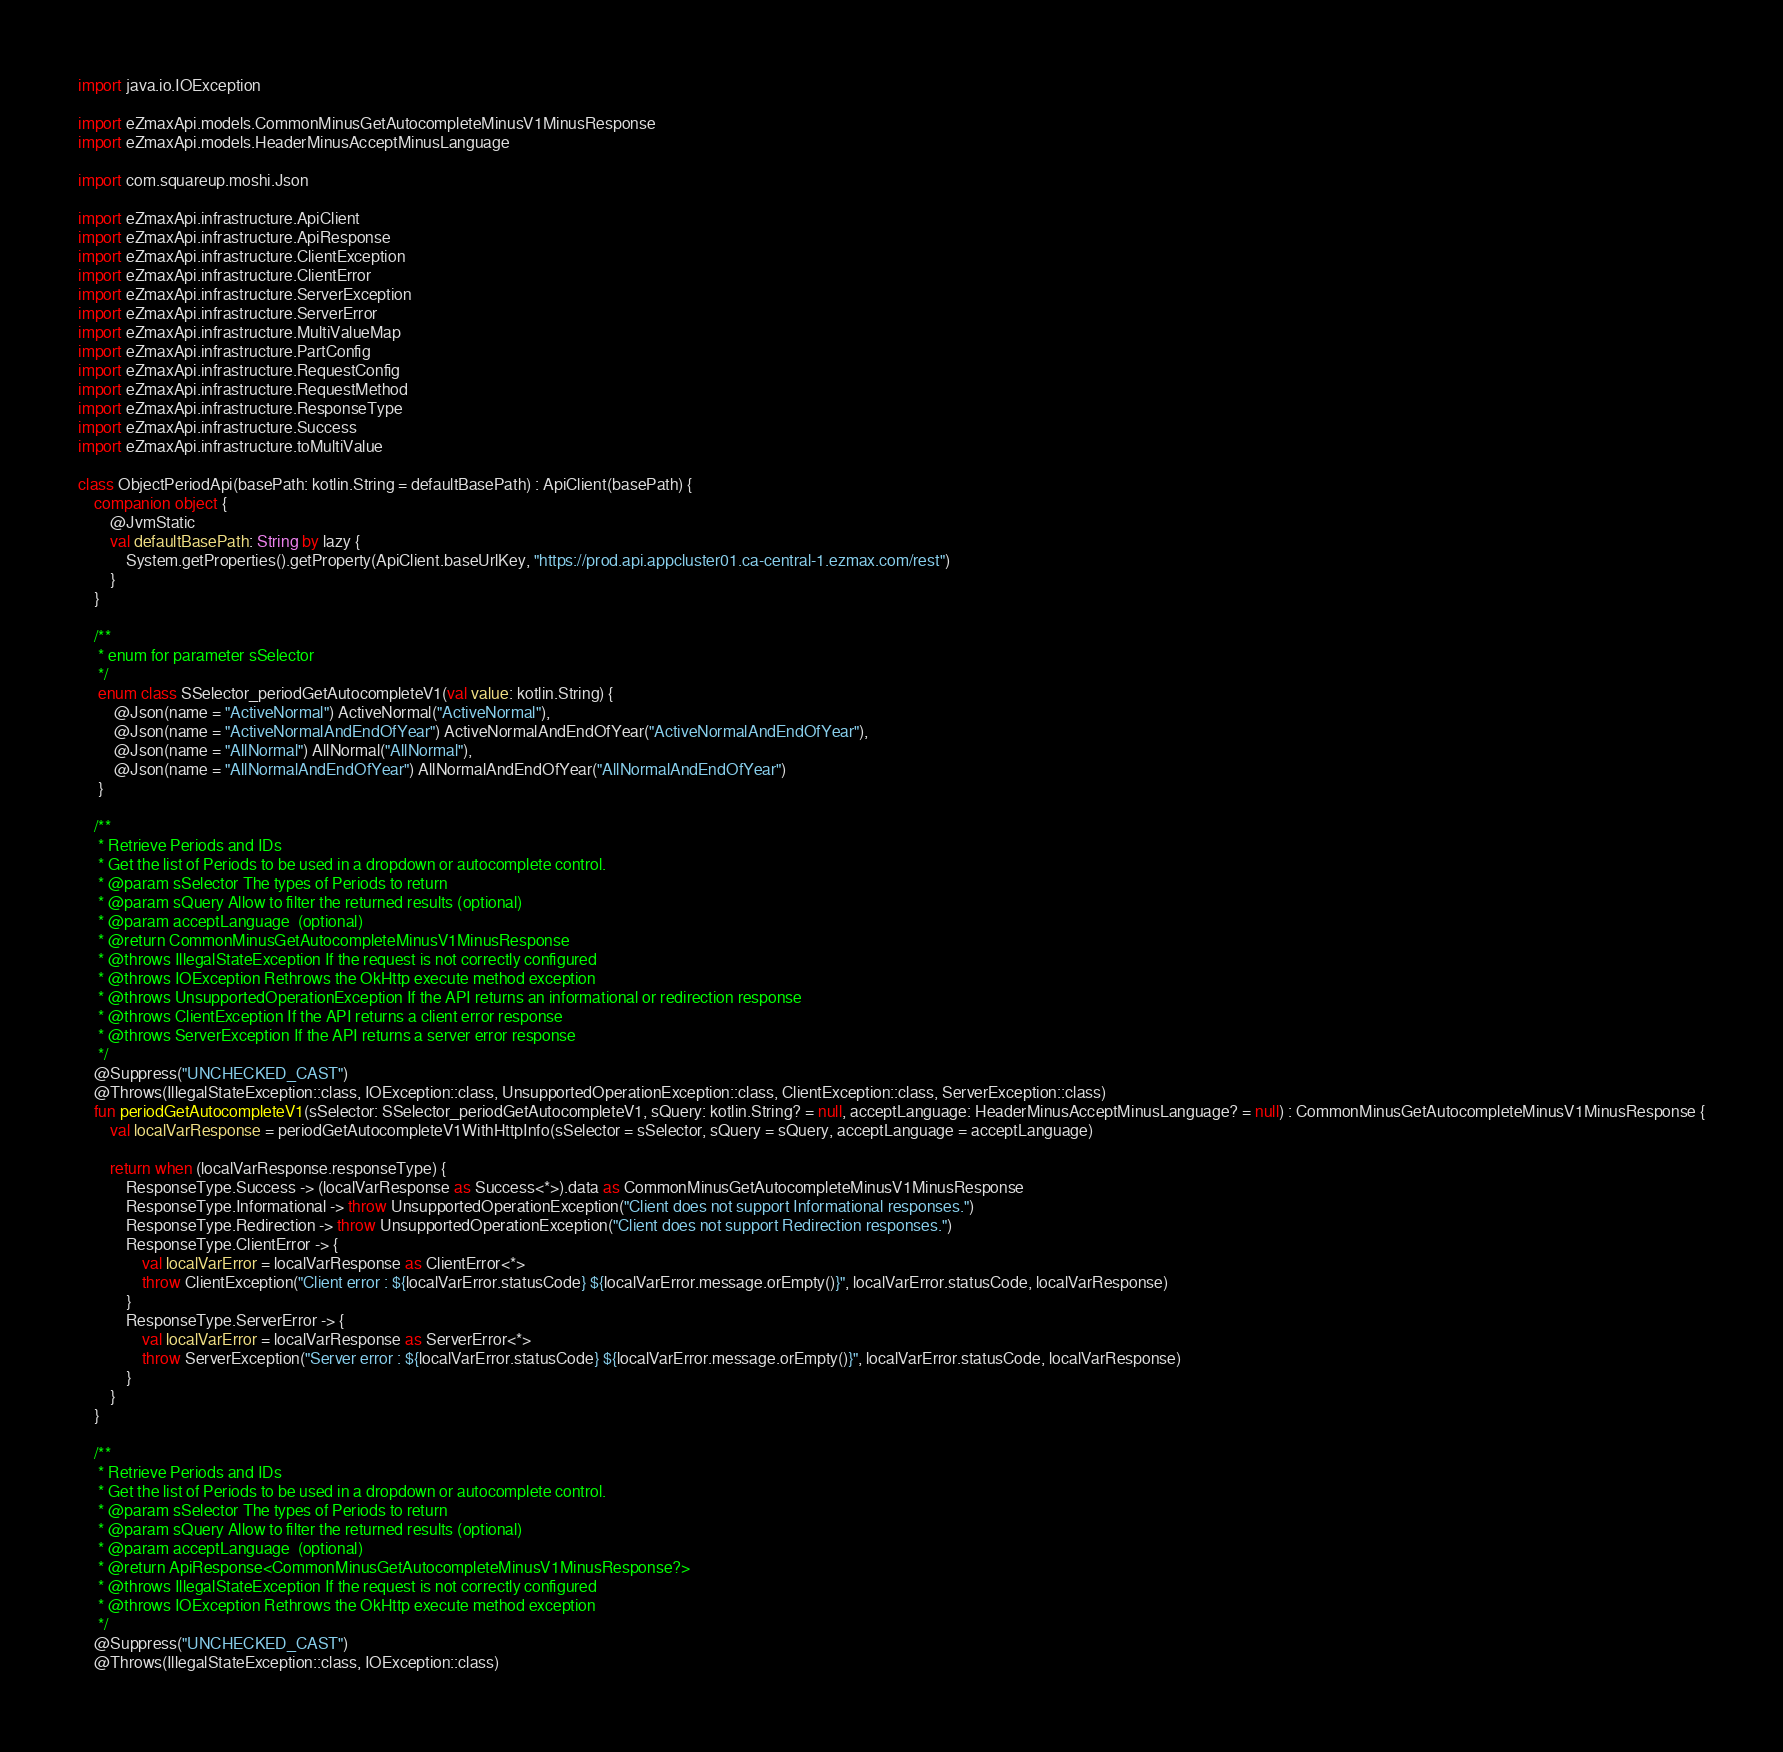Convert code to text. <code><loc_0><loc_0><loc_500><loc_500><_Kotlin_>import java.io.IOException

import eZmaxApi.models.CommonMinusGetAutocompleteMinusV1MinusResponse
import eZmaxApi.models.HeaderMinusAcceptMinusLanguage

import com.squareup.moshi.Json

import eZmaxApi.infrastructure.ApiClient
import eZmaxApi.infrastructure.ApiResponse
import eZmaxApi.infrastructure.ClientException
import eZmaxApi.infrastructure.ClientError
import eZmaxApi.infrastructure.ServerException
import eZmaxApi.infrastructure.ServerError
import eZmaxApi.infrastructure.MultiValueMap
import eZmaxApi.infrastructure.PartConfig
import eZmaxApi.infrastructure.RequestConfig
import eZmaxApi.infrastructure.RequestMethod
import eZmaxApi.infrastructure.ResponseType
import eZmaxApi.infrastructure.Success
import eZmaxApi.infrastructure.toMultiValue

class ObjectPeriodApi(basePath: kotlin.String = defaultBasePath) : ApiClient(basePath) {
    companion object {
        @JvmStatic
        val defaultBasePath: String by lazy {
            System.getProperties().getProperty(ApiClient.baseUrlKey, "https://prod.api.appcluster01.ca-central-1.ezmax.com/rest")
        }
    }

    /**
     * enum for parameter sSelector
     */
     enum class SSelector_periodGetAutocompleteV1(val value: kotlin.String) {
         @Json(name = "ActiveNormal") ActiveNormal("ActiveNormal"),
         @Json(name = "ActiveNormalAndEndOfYear") ActiveNormalAndEndOfYear("ActiveNormalAndEndOfYear"),
         @Json(name = "AllNormal") AllNormal("AllNormal"),
         @Json(name = "AllNormalAndEndOfYear") AllNormalAndEndOfYear("AllNormalAndEndOfYear")
     }

    /**
     * Retrieve Periods and IDs
     * Get the list of Periods to be used in a dropdown or autocomplete control.
     * @param sSelector The types of Periods to return
     * @param sQuery Allow to filter the returned results (optional)
     * @param acceptLanguage  (optional)
     * @return CommonMinusGetAutocompleteMinusV1MinusResponse
     * @throws IllegalStateException If the request is not correctly configured
     * @throws IOException Rethrows the OkHttp execute method exception
     * @throws UnsupportedOperationException If the API returns an informational or redirection response
     * @throws ClientException If the API returns a client error response
     * @throws ServerException If the API returns a server error response
     */
    @Suppress("UNCHECKED_CAST")
    @Throws(IllegalStateException::class, IOException::class, UnsupportedOperationException::class, ClientException::class, ServerException::class)
    fun periodGetAutocompleteV1(sSelector: SSelector_periodGetAutocompleteV1, sQuery: kotlin.String? = null, acceptLanguage: HeaderMinusAcceptMinusLanguage? = null) : CommonMinusGetAutocompleteMinusV1MinusResponse {
        val localVarResponse = periodGetAutocompleteV1WithHttpInfo(sSelector = sSelector, sQuery = sQuery, acceptLanguage = acceptLanguage)

        return when (localVarResponse.responseType) {
            ResponseType.Success -> (localVarResponse as Success<*>).data as CommonMinusGetAutocompleteMinusV1MinusResponse
            ResponseType.Informational -> throw UnsupportedOperationException("Client does not support Informational responses.")
            ResponseType.Redirection -> throw UnsupportedOperationException("Client does not support Redirection responses.")
            ResponseType.ClientError -> {
                val localVarError = localVarResponse as ClientError<*>
                throw ClientException("Client error : ${localVarError.statusCode} ${localVarError.message.orEmpty()}", localVarError.statusCode, localVarResponse)
            }
            ResponseType.ServerError -> {
                val localVarError = localVarResponse as ServerError<*>
                throw ServerException("Server error : ${localVarError.statusCode} ${localVarError.message.orEmpty()}", localVarError.statusCode, localVarResponse)
            }
        }
    }

    /**
     * Retrieve Periods and IDs
     * Get the list of Periods to be used in a dropdown or autocomplete control.
     * @param sSelector The types of Periods to return
     * @param sQuery Allow to filter the returned results (optional)
     * @param acceptLanguage  (optional)
     * @return ApiResponse<CommonMinusGetAutocompleteMinusV1MinusResponse?>
     * @throws IllegalStateException If the request is not correctly configured
     * @throws IOException Rethrows the OkHttp execute method exception
     */
    @Suppress("UNCHECKED_CAST")
    @Throws(IllegalStateException::class, IOException::class)</code> 